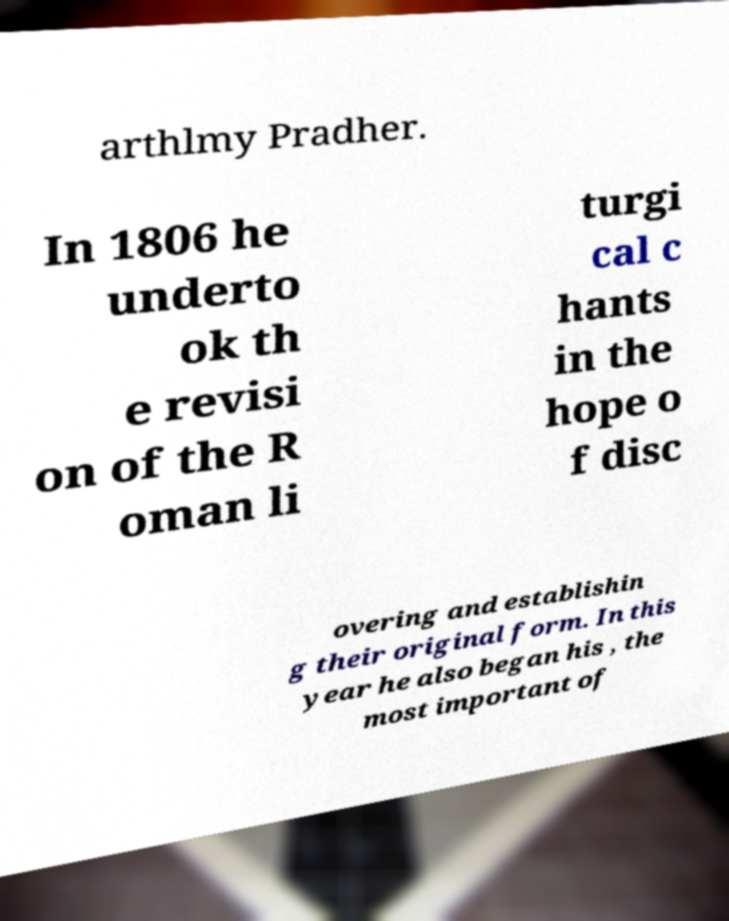Could you assist in decoding the text presented in this image and type it out clearly? arthlmy Pradher. In 1806 he underto ok th e revisi on of the R oman li turgi cal c hants in the hope o f disc overing and establishin g their original form. In this year he also began his , the most important of 